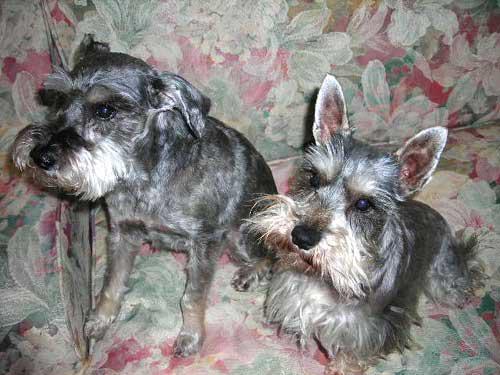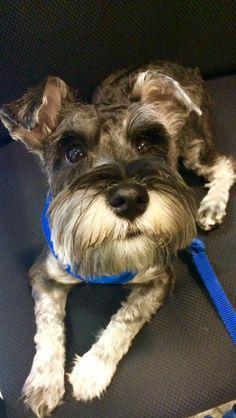The first image is the image on the left, the second image is the image on the right. Given the left and right images, does the statement "In one image, there are two Miniature Schnauzers sitting on some furniture." hold true? Answer yes or no. Yes. The first image is the image on the left, the second image is the image on the right. For the images shown, is this caption "Some of the dogs are inside and the others are outside in the grass." true? Answer yes or no. No. 